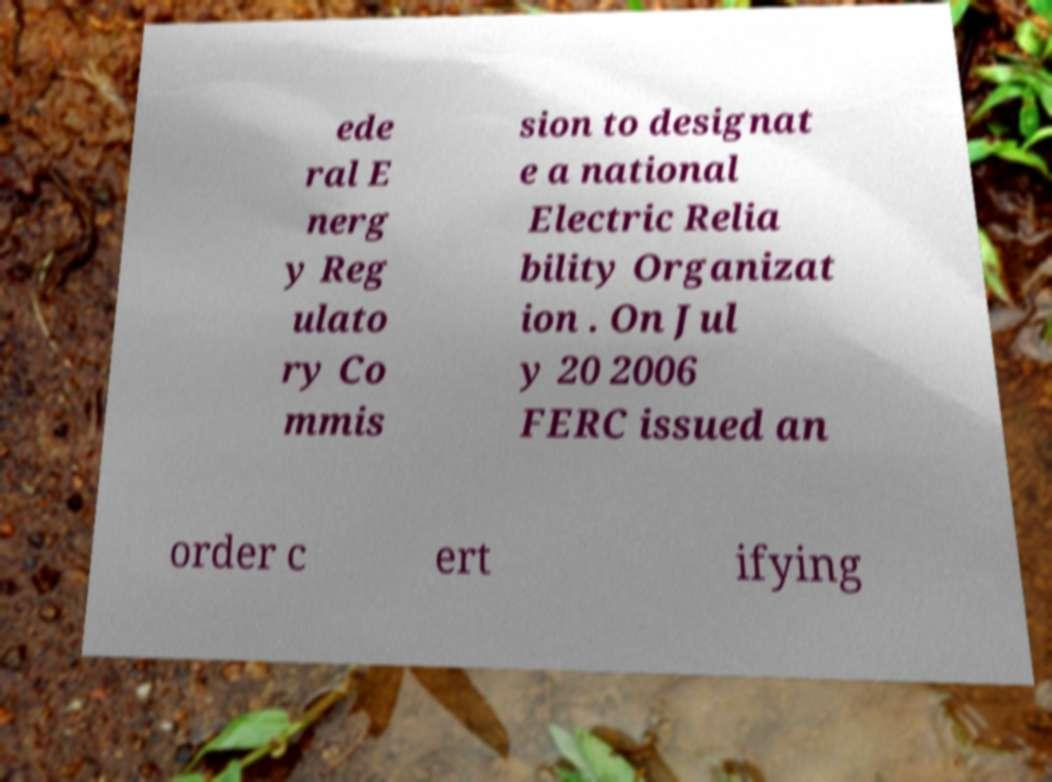Could you assist in decoding the text presented in this image and type it out clearly? ede ral E nerg y Reg ulato ry Co mmis sion to designat e a national Electric Relia bility Organizat ion . On Jul y 20 2006 FERC issued an order c ert ifying 